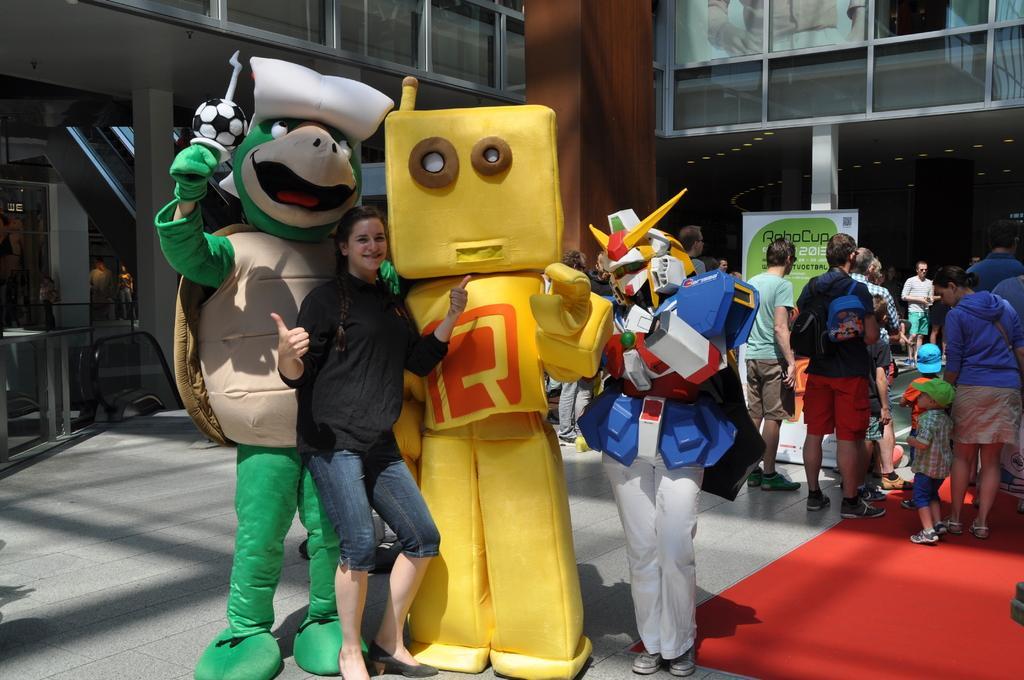How would you summarize this image in a sentence or two? In this image we can see three persons with toy costumes. In the background we can see the people. Some are standing on the path and some are on the red carpet. We can also see the glass windows and pillars and also the roof. We can also see the poster with text. 